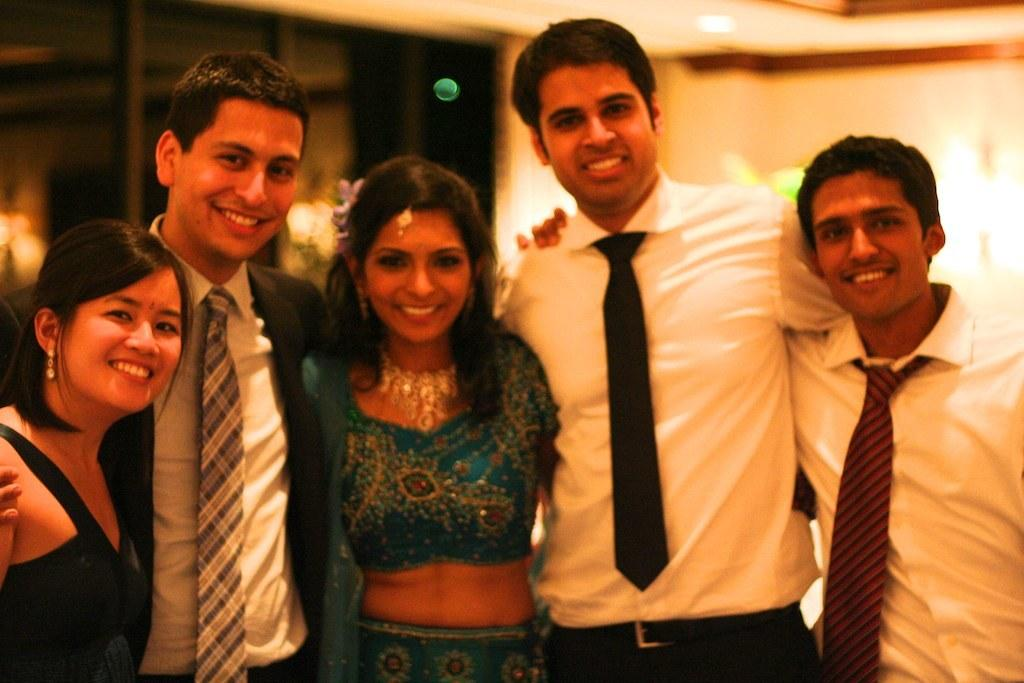What is the main subject of the image? The main subject of the image is a group of people. What are the people in the image doing? The people are standing and smiling. What can be seen in the background of the image? There is a wall, lights, and a glass window in the background of the image. What type of yak can be seen grazing near the people in the image? There is no yak present in the image; it features a group of people standing and smiling. What material is the brass step made of in the image? There is no brass step present in the image. 